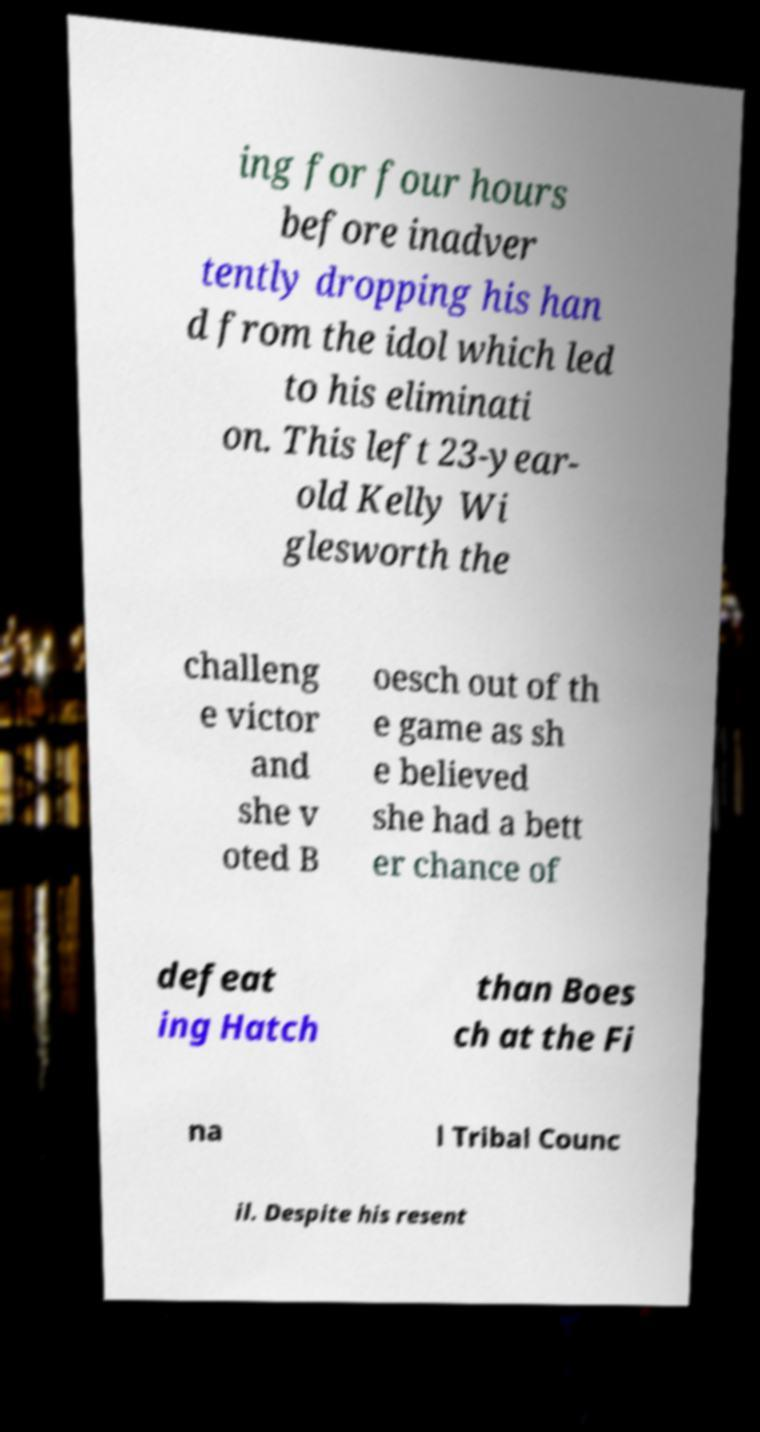Could you extract and type out the text from this image? ing for four hours before inadver tently dropping his han d from the idol which led to his eliminati on. This left 23-year- old Kelly Wi glesworth the challeng e victor and she v oted B oesch out of th e game as sh e believed she had a bett er chance of defeat ing Hatch than Boes ch at the Fi na l Tribal Counc il. Despite his resent 